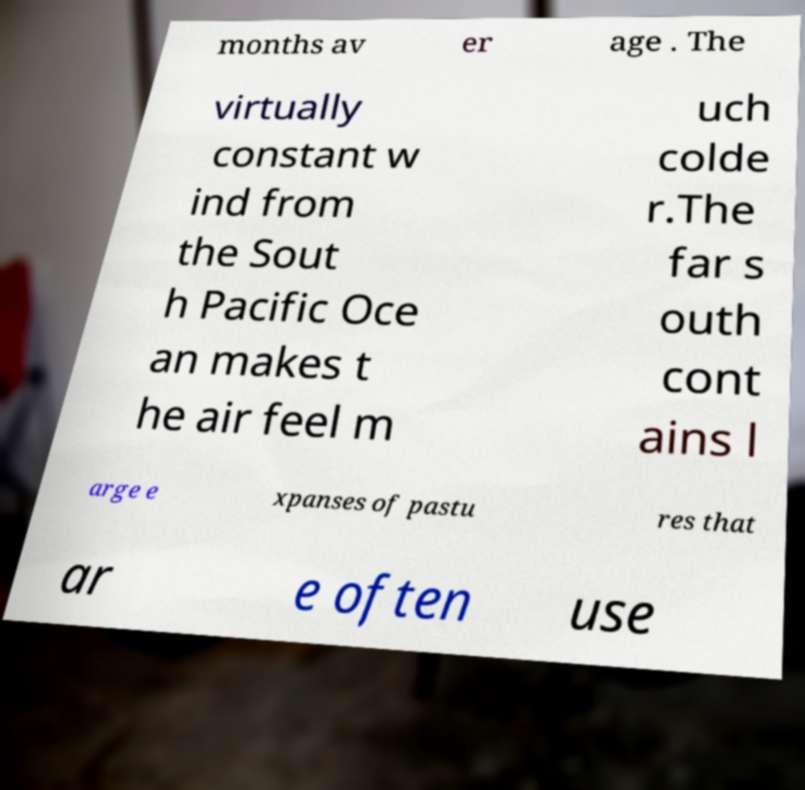What messages or text are displayed in this image? I need them in a readable, typed format. months av er age . The virtually constant w ind from the Sout h Pacific Oce an makes t he air feel m uch colde r.The far s outh cont ains l arge e xpanses of pastu res that ar e often use 